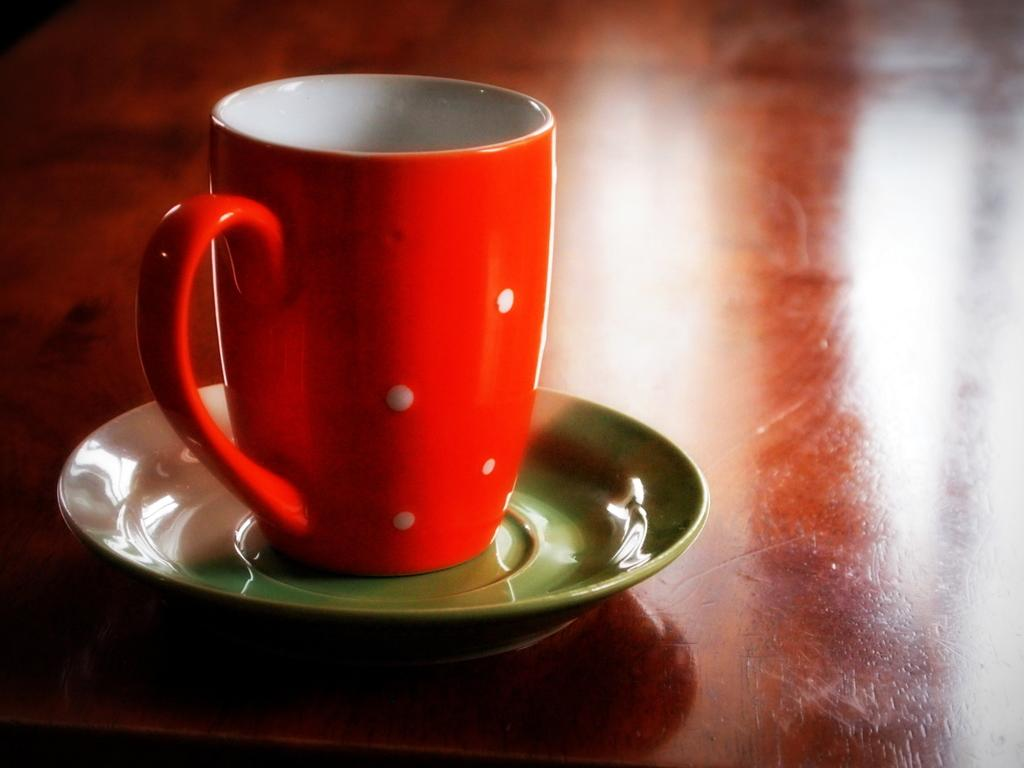What is the color of the table in the image? The table in the image is brown. What is placed on the table? A red cup and saucer are placed on the table. Can you describe the background of the image? The background of the image is blurred. Who is the creator of the recess in the image? There is no recess present in the image, so it is not possible to determine who the creator might be. 